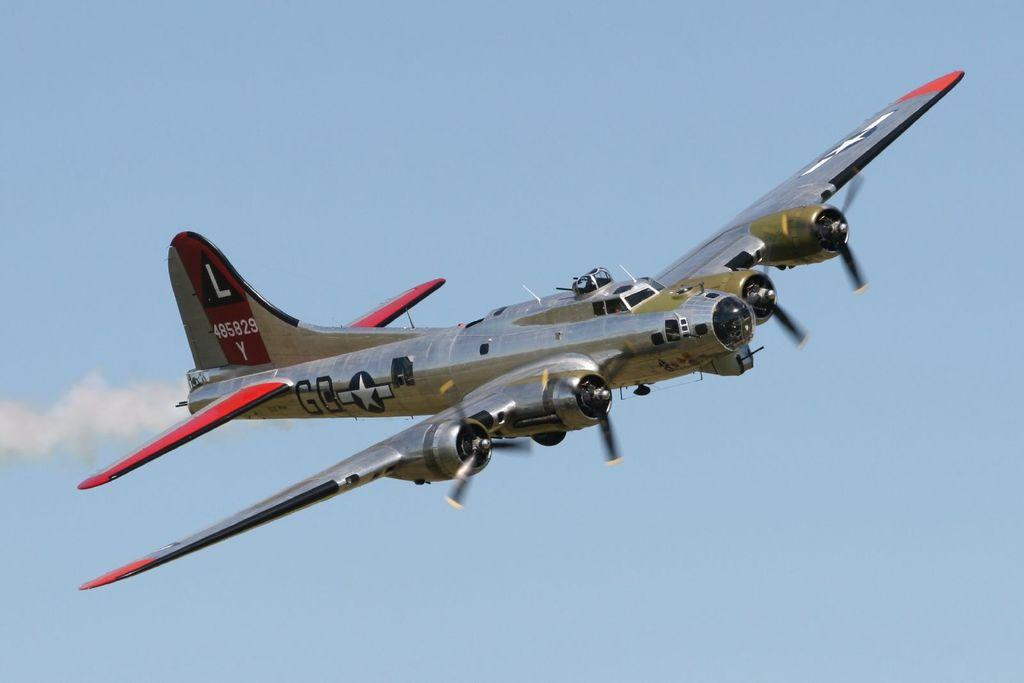<image>
Give a short and clear explanation of the subsequent image. an old propeller plane has numbers 485829Y on its tail fin 